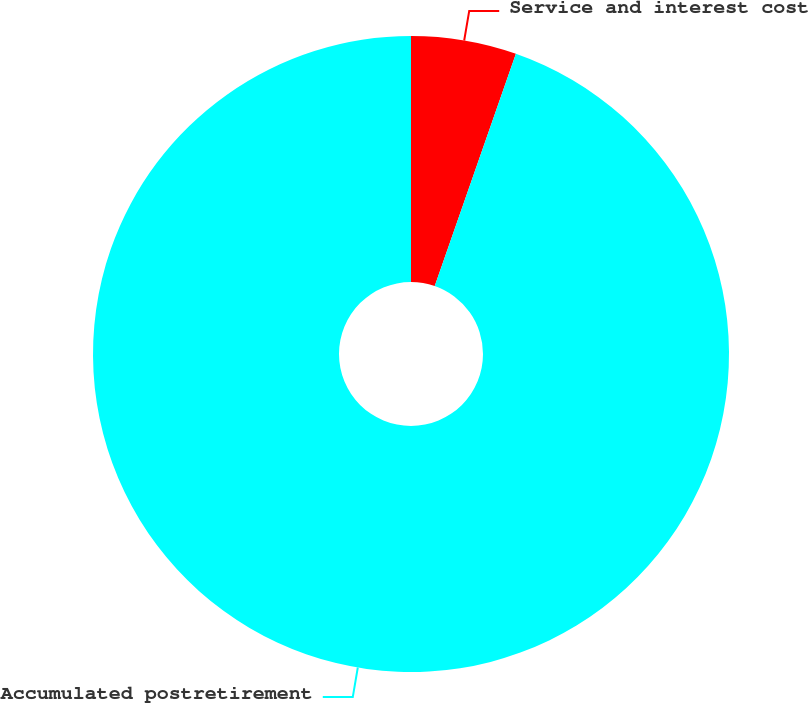Convert chart. <chart><loc_0><loc_0><loc_500><loc_500><pie_chart><fcel>Service and interest cost<fcel>Accumulated postretirement<nl><fcel>5.35%<fcel>94.65%<nl></chart> 